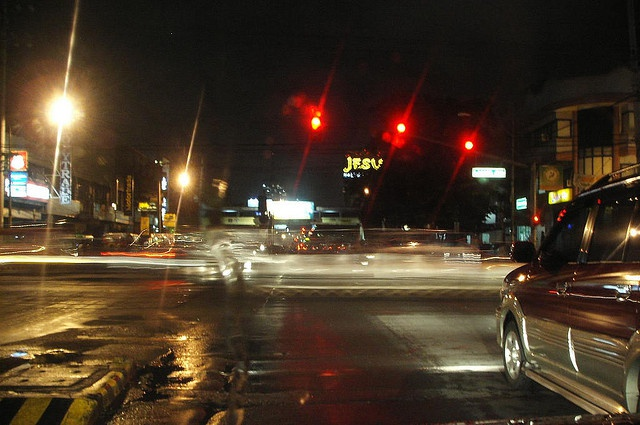Describe the objects in this image and their specific colors. I can see car in black, gray, and maroon tones, traffic light in black, maroon, red, and ivory tones, traffic light in black, red, brown, maroon, and ivory tones, traffic light in black, ivory, yellow, and khaki tones, and traffic light in black, brown, red, maroon, and khaki tones in this image. 